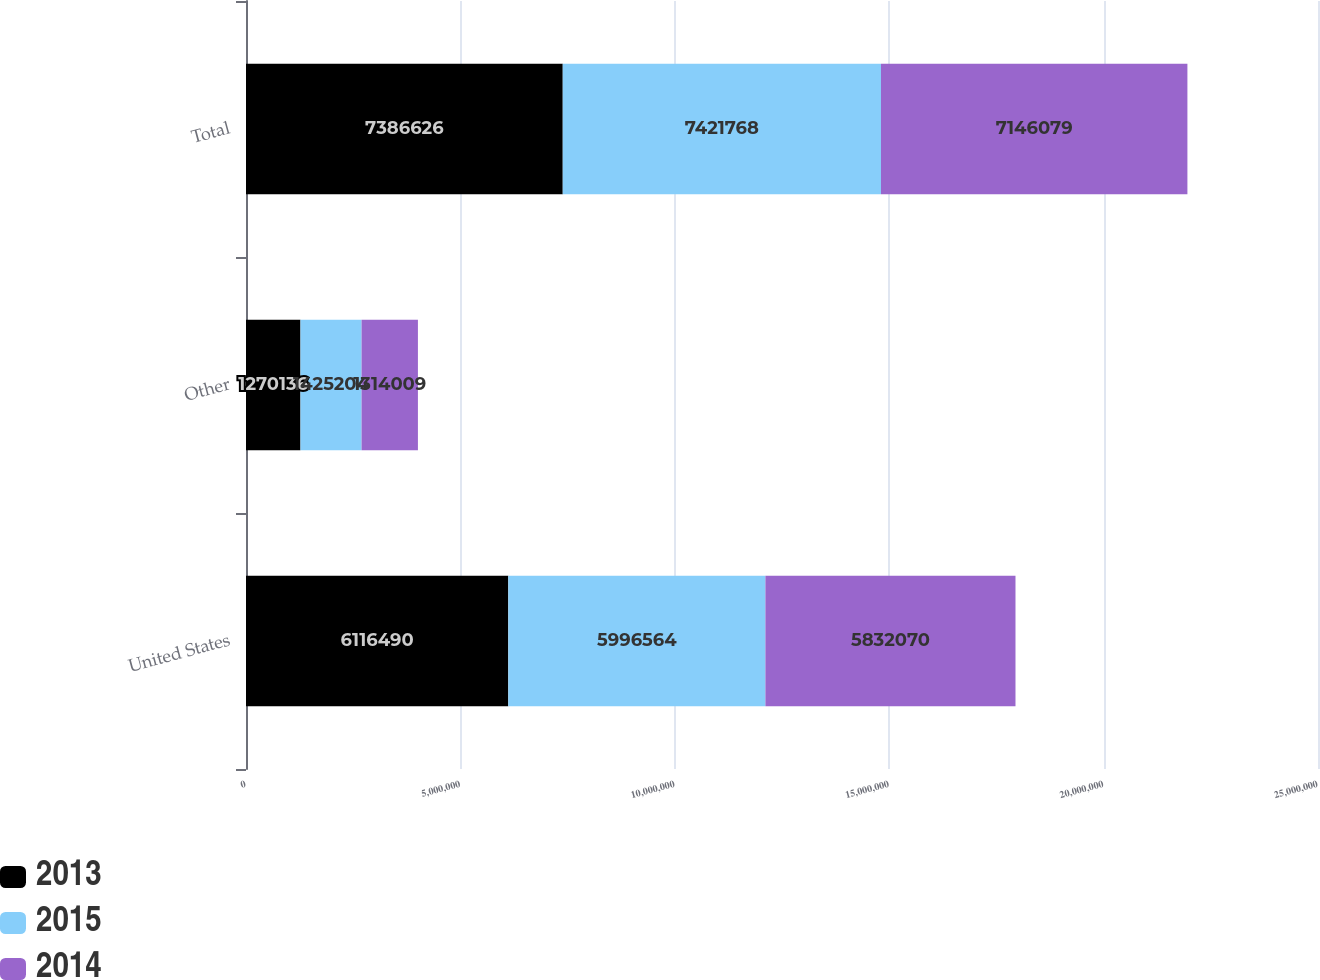<chart> <loc_0><loc_0><loc_500><loc_500><stacked_bar_chart><ecel><fcel>United States<fcel>Other<fcel>Total<nl><fcel>2013<fcel>6.11649e+06<fcel>1.27014e+06<fcel>7.38663e+06<nl><fcel>2015<fcel>5.99656e+06<fcel>1.4252e+06<fcel>7.42177e+06<nl><fcel>2014<fcel>5.83207e+06<fcel>1.31401e+06<fcel>7.14608e+06<nl></chart> 